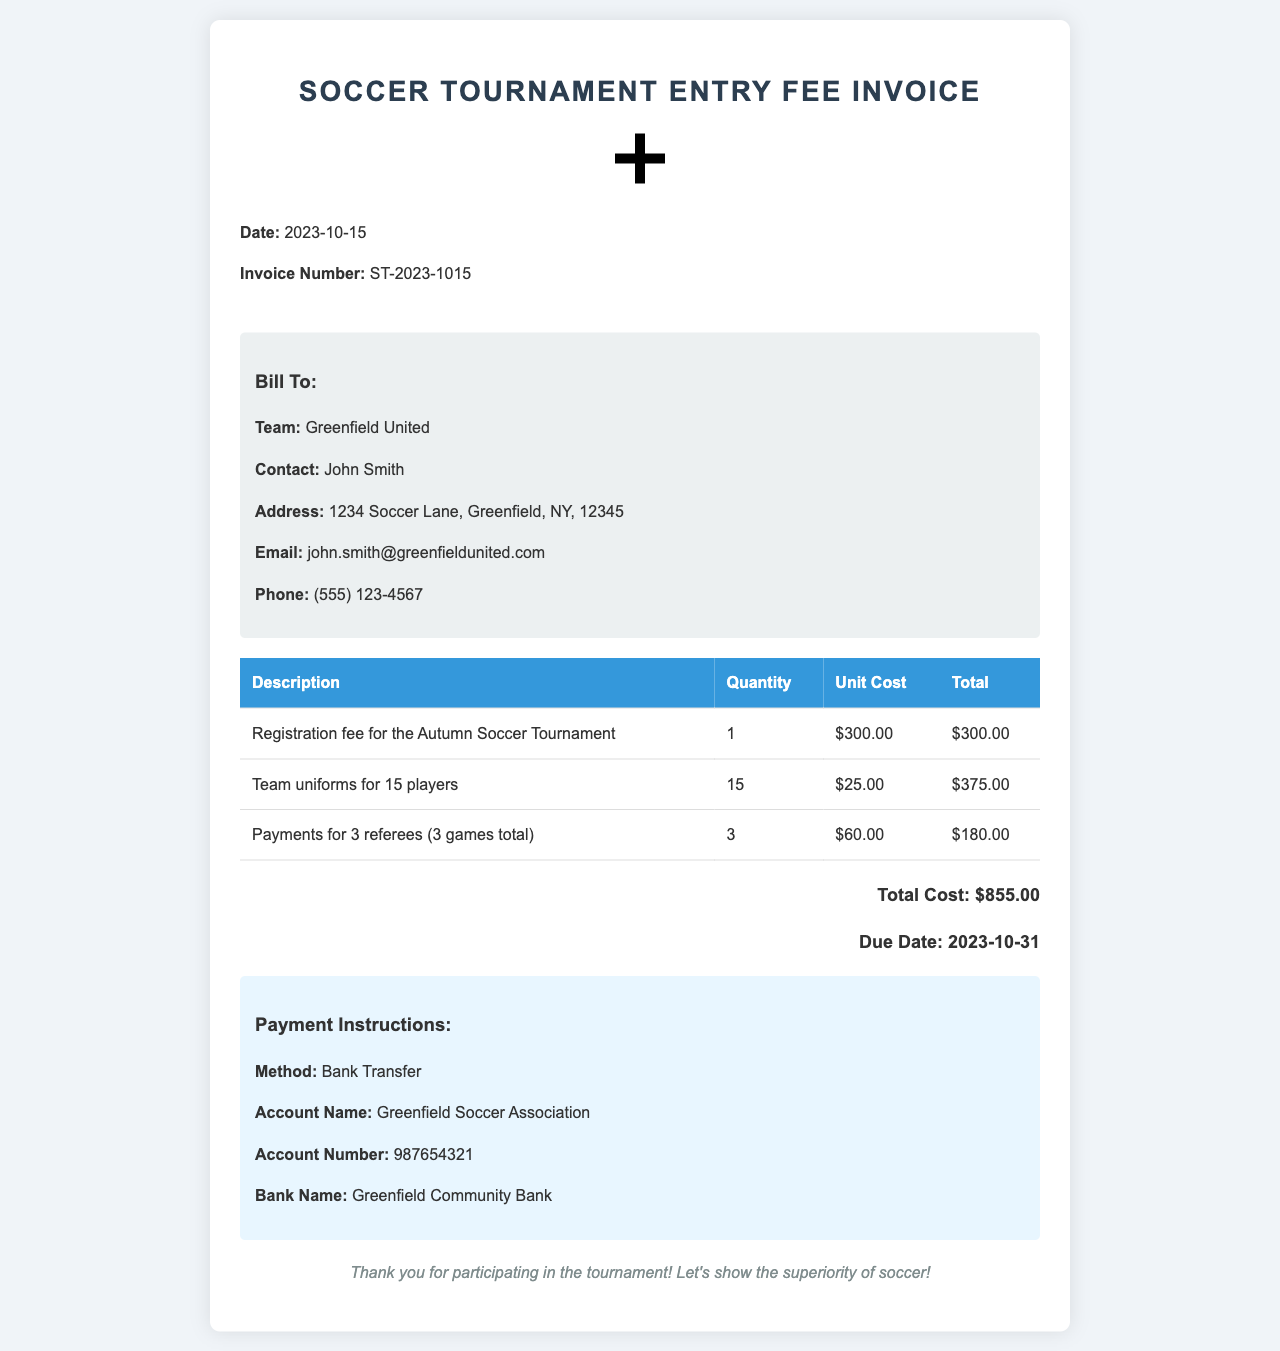What is the invoice number? The invoice number can be found in the header of the document, which specifies the identification for the invoice.
Answer: ST-2023-1015 What is the total cost? The total cost is calculated by adding the individual costs of the entries listed in the invoice.
Answer: $855.00 Who should the payment be made to? The payment instructions specify the account name to which the payment should be transferred.
Answer: Greenfield Soccer Association How many players' uniforms were ordered? The entry for team uniforms indicates the quantity of uniforms ordered, which is listed in the details.
Answer: 15 What is the due date for the payment? The due date for payment is provided in the total cost section of the document.
Answer: 2023-10-31 What is the registration fee? The registration fee is noted in the table as a total cost for entering the tournament.
Answer: $300.00 Why are there payments for referees? The payments for referees are specified in the invoice as part of the tournament organization and game officiating costs.
Answer: 3 referees What method of payment is specified? The payment instructions detail the method of payment accepted for this invoice.
Answer: Bank Transfer What is the contact email for the team? The contact email for the team is provided in the bill-to section of the document.
Answer: john.smith@greenfieldunited.com 